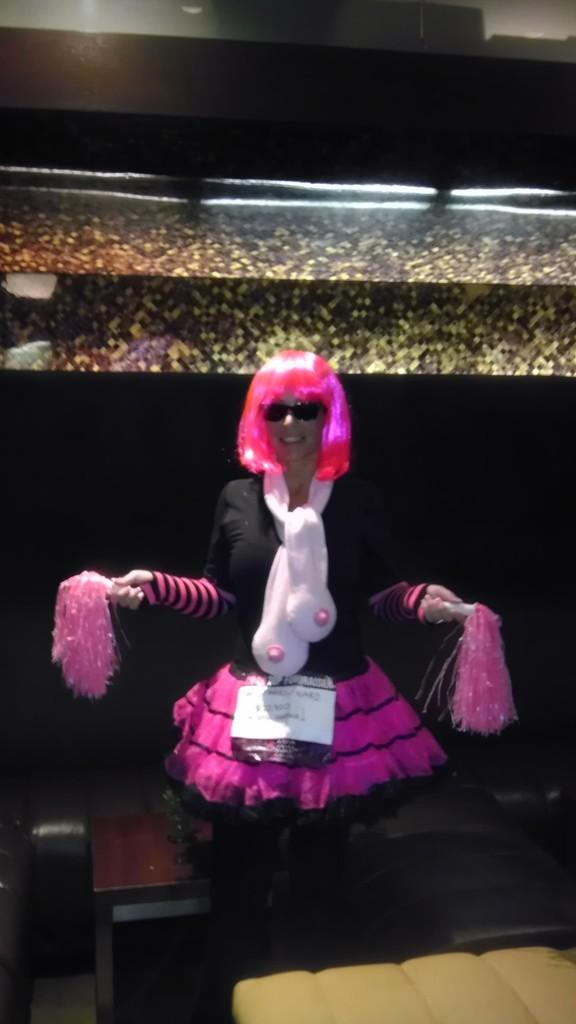What is a notable characteristic of the person in the image? The person in the image has pink hair. What is the person holding in the image? The person is holding pink objects. What type of furniture can be seen in the image? There are tables in the image. What is located above the person in the image? There is an object above the person. What color is the background of the image? The background of the image is black. What type of porter is assisting the person in the image? There is no porter present in the image. What connection does the person in the image have with the object above them? The image does not provide any information about a connection between the person and the object above them. 